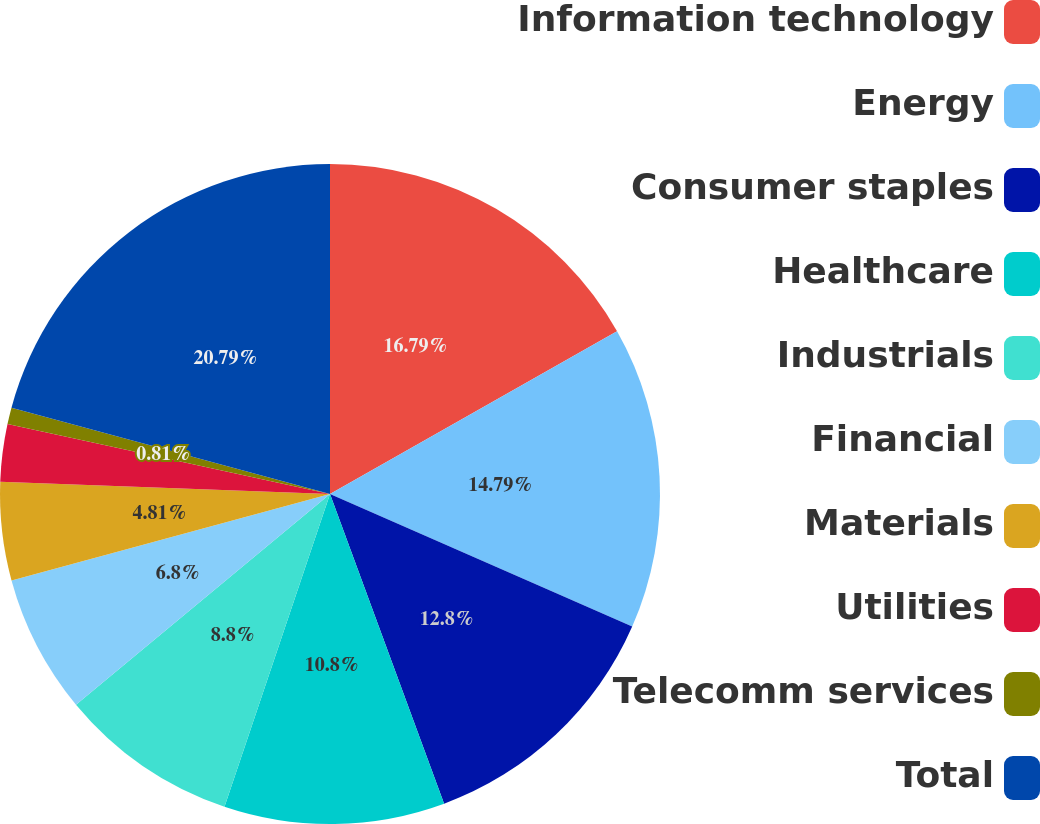Convert chart. <chart><loc_0><loc_0><loc_500><loc_500><pie_chart><fcel>Information technology<fcel>Energy<fcel>Consumer staples<fcel>Healthcare<fcel>Industrials<fcel>Financial<fcel>Materials<fcel>Utilities<fcel>Telecomm services<fcel>Total<nl><fcel>16.79%<fcel>14.79%<fcel>12.8%<fcel>10.8%<fcel>8.8%<fcel>6.8%<fcel>4.81%<fcel>2.81%<fcel>0.81%<fcel>20.79%<nl></chart> 